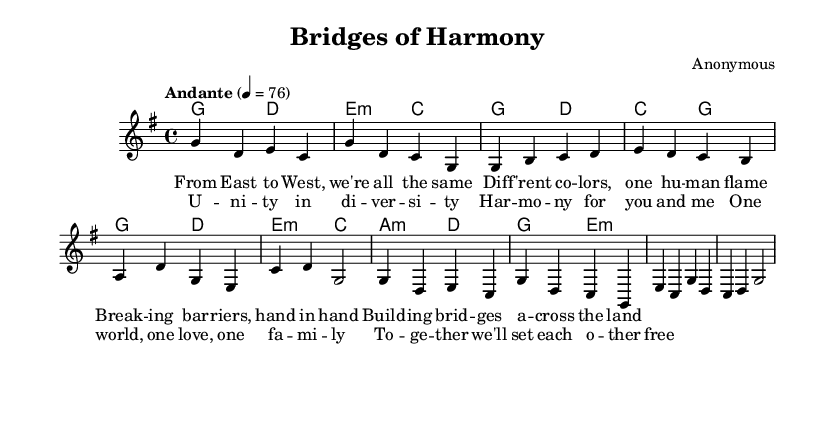What is the key signature of this music? The key signature is indicated by the 'g' in the global context, which signifies G major. G major has one sharp (F#).
Answer: G major What is the time signature of this music? The time signature is shown in the global context as '4/4', which means there are four beats in each measure and a quarter note gets one beat.
Answer: 4/4 What is the tempo marking for this piece? The tempo marking is specified as "Andante" with a metronome marking of 76, indicating a moderately slow tempo.
Answer: Andante How many measures are in the verse section? The verse is composed of four lines, each containing four measures, resulting in a total of 16 measures in the verse section.
Answer: 16 What is the primary theme expressed in the lyrics? The lyrics reflect the idea of unity and harmony across cultures, emphasizing breaking barriers and building bridges.
Answer: Unity and harmony Which chord appears most frequently in the harmony section? Examining the harmony notes, 'G' is played repeatedly as one of the main chords in the progression throughout the piece.
Answer: G What lyrical device is used in the chorus? The chorus employs repetition in the phrase "One world, one love, one family," which emphasizes the theme of collective unity.
Answer: Repetition 